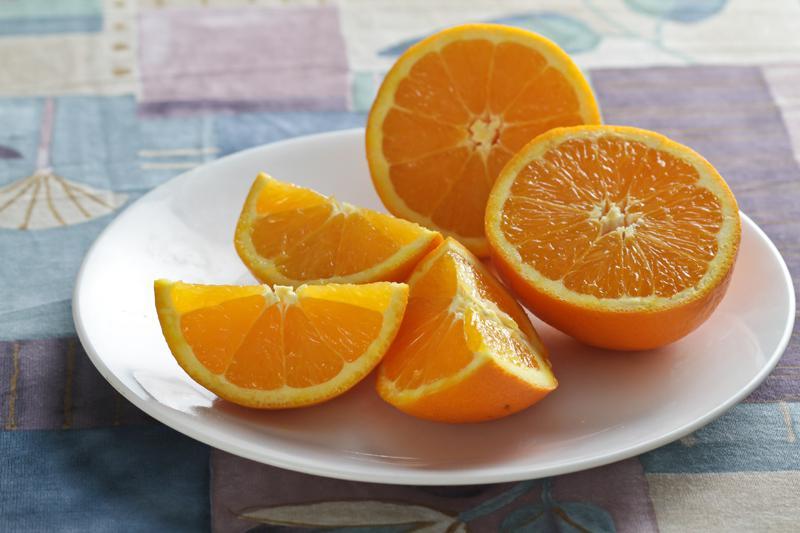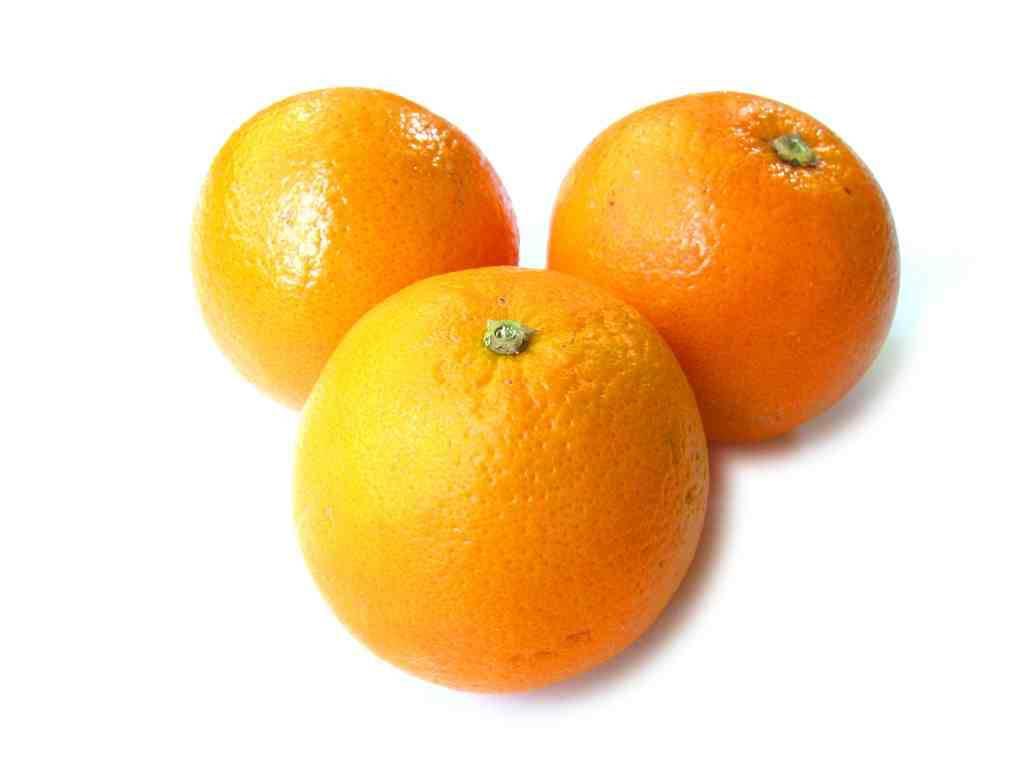The first image is the image on the left, the second image is the image on the right. Given the left and right images, does the statement "There is at least one unsliced orange." hold true? Answer yes or no. Yes. 